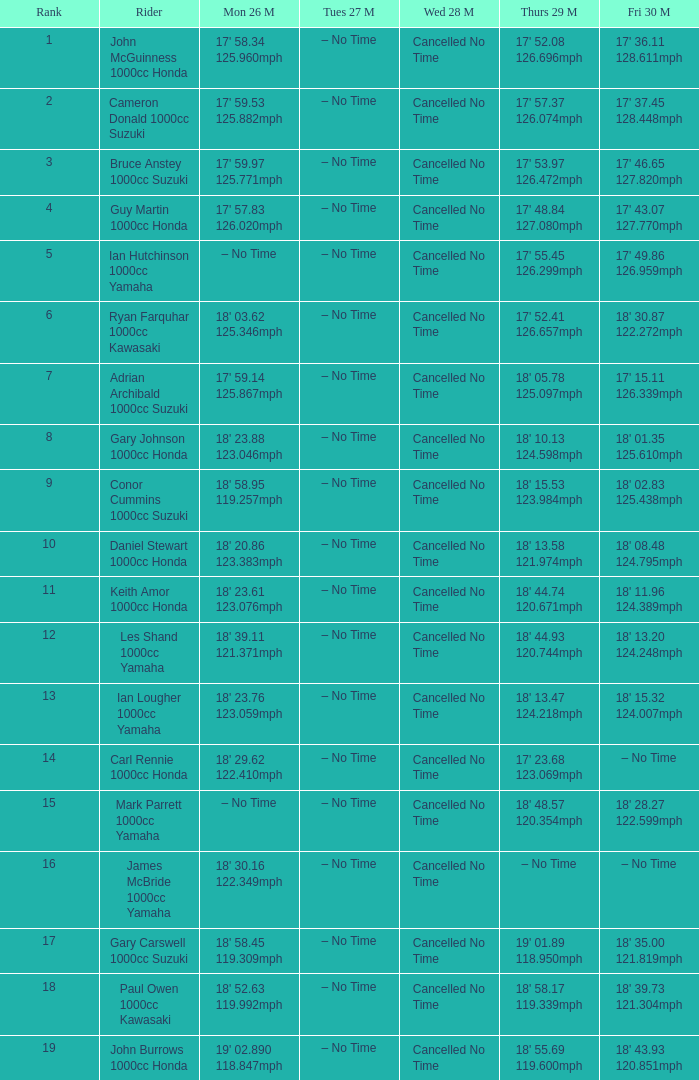What time is mon may 26 and fri may 30 is 18' 28.27 122.599mph? – No Time. 